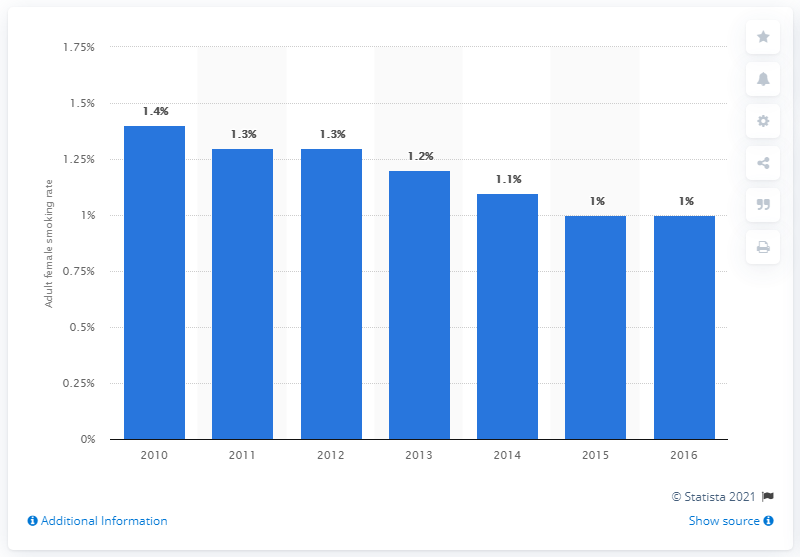Point out several critical features in this image. Since 2010, the smoking prevalence rate of females in Malaysia has decreased. 